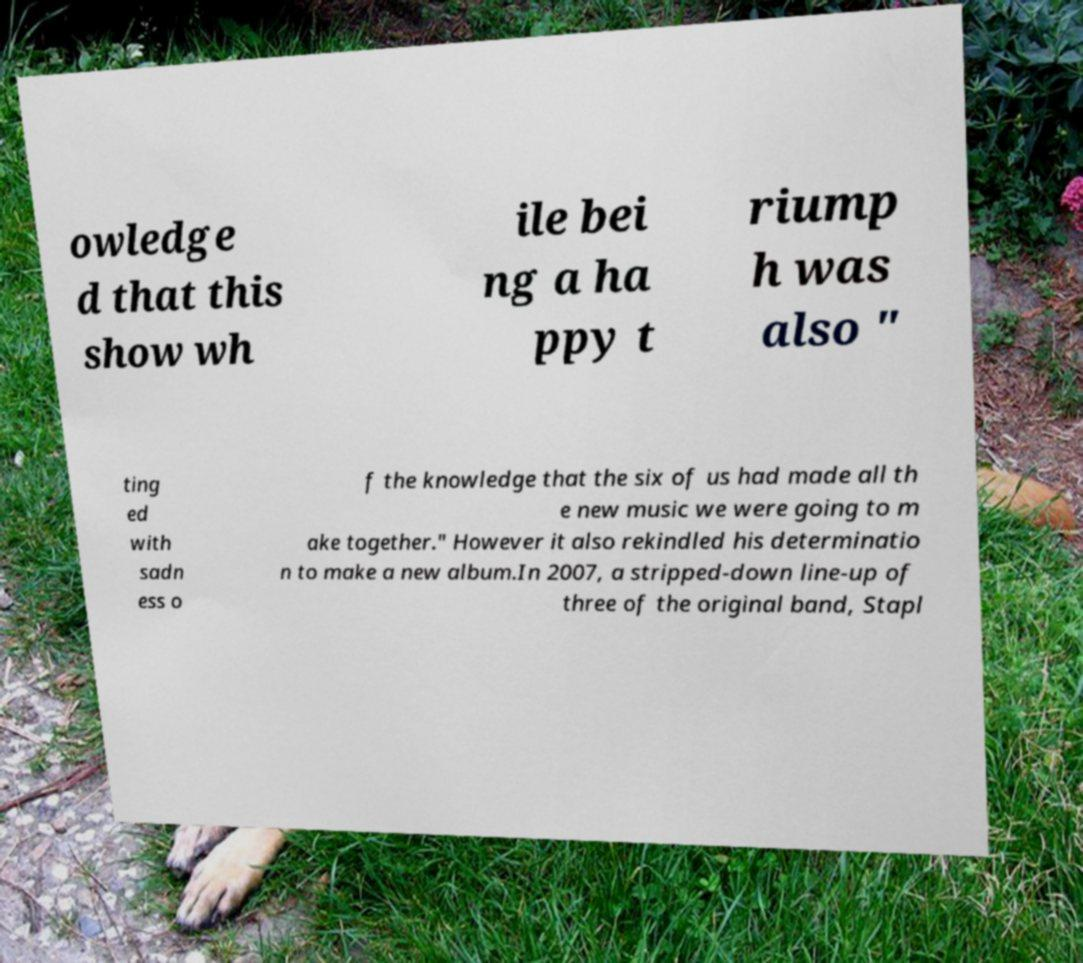Please read and relay the text visible in this image. What does it say? owledge d that this show wh ile bei ng a ha ppy t riump h was also " ting ed with sadn ess o f the knowledge that the six of us had made all th e new music we were going to m ake together." However it also rekindled his determinatio n to make a new album.In 2007, a stripped-down line-up of three of the original band, Stapl 